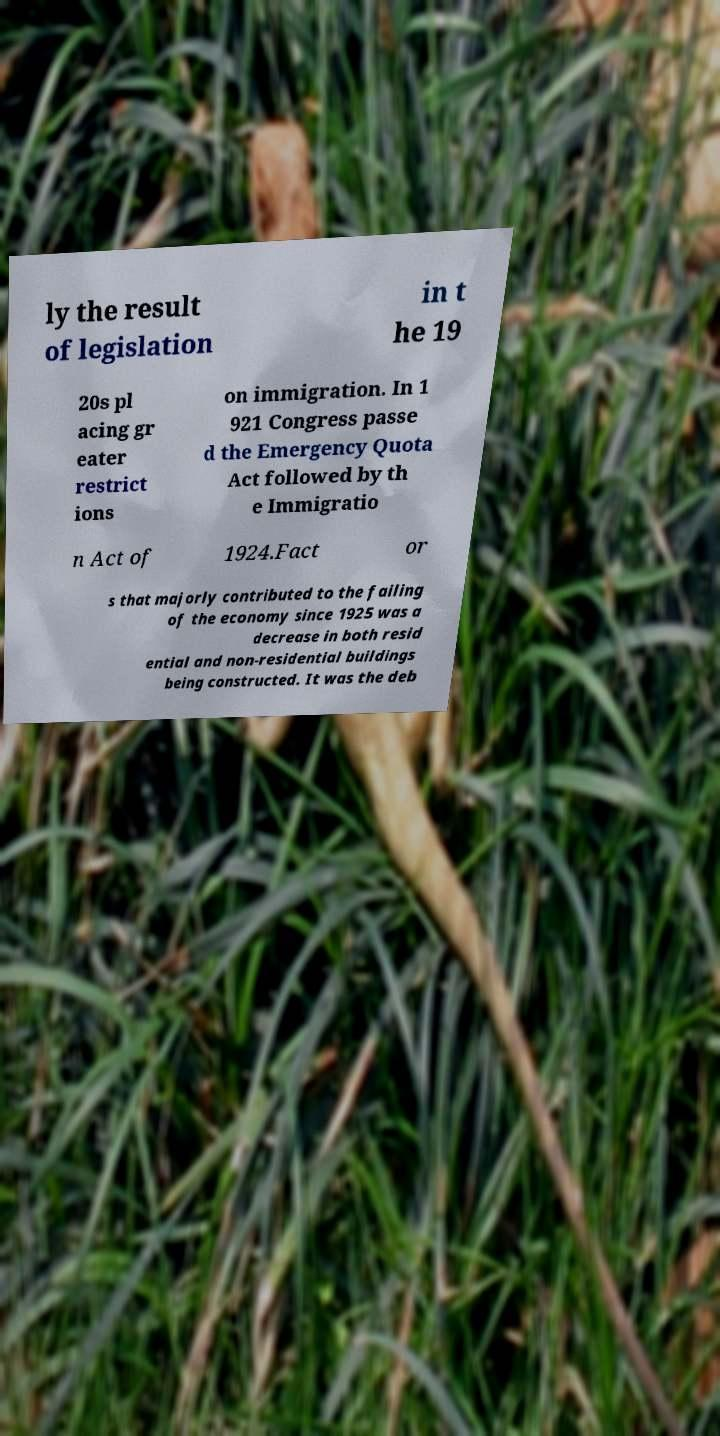Can you read and provide the text displayed in the image?This photo seems to have some interesting text. Can you extract and type it out for me? ly the result of legislation in t he 19 20s pl acing gr eater restrict ions on immigration. In 1 921 Congress passe d the Emergency Quota Act followed by th e Immigratio n Act of 1924.Fact or s that majorly contributed to the failing of the economy since 1925 was a decrease in both resid ential and non-residential buildings being constructed. It was the deb 